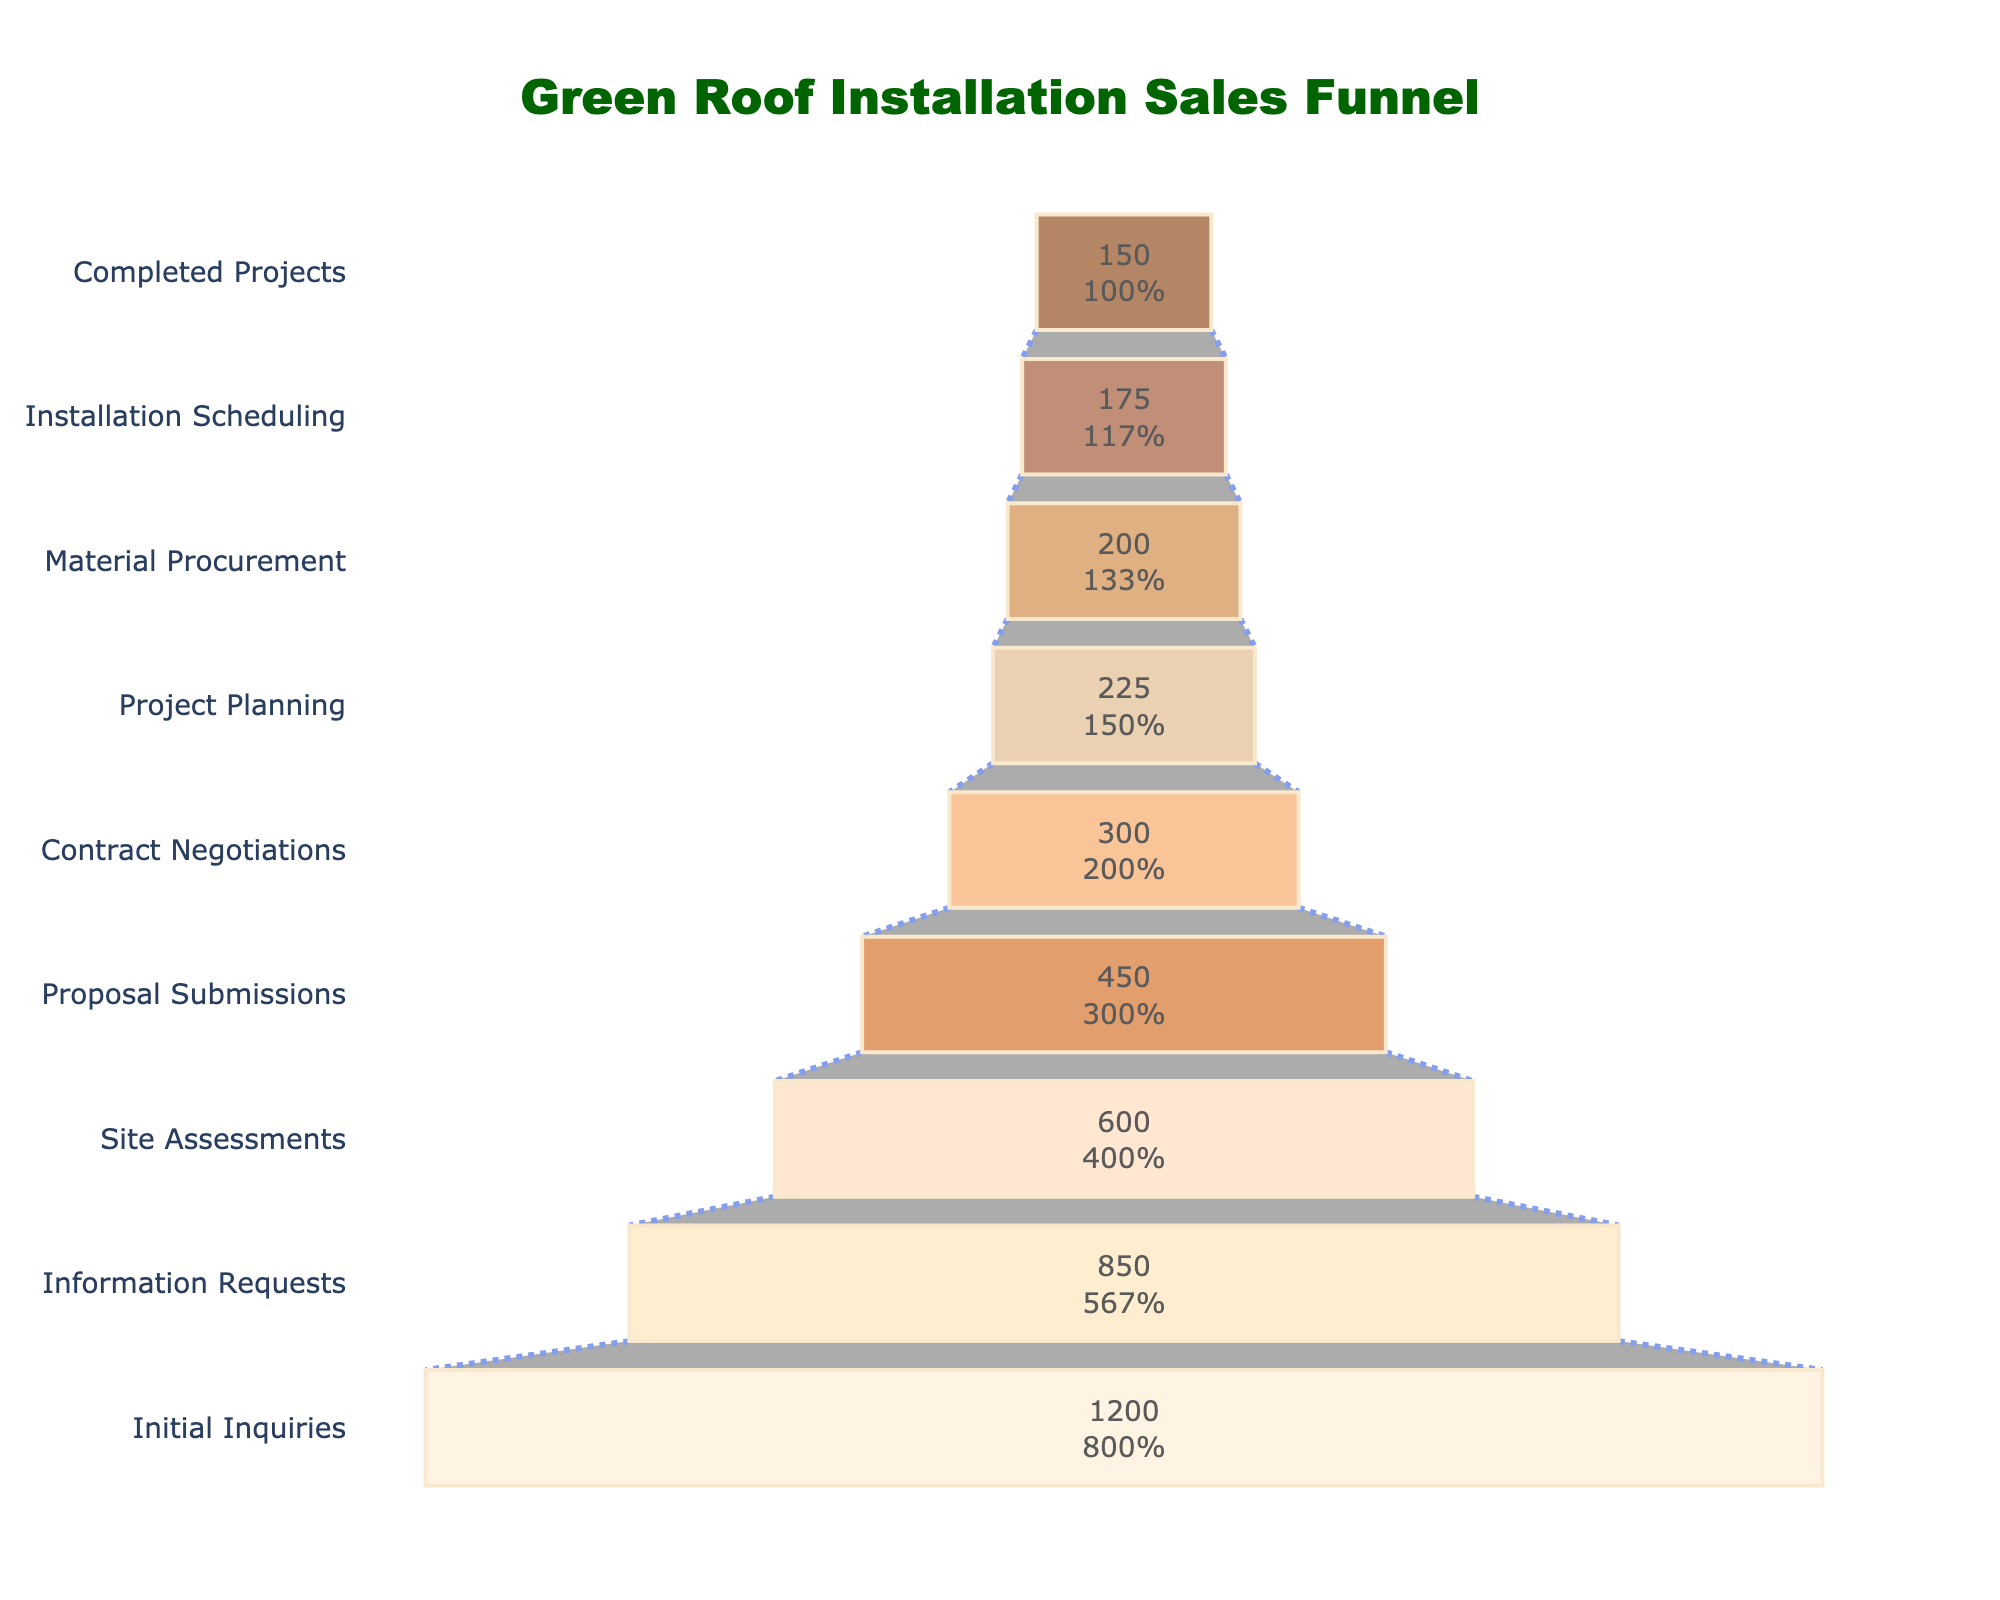what is the title of the figure? The title of the figure is shown at the top of the chart. It reads "Green Roof Installation Sales Funnel."
Answer: Green Roof Installation Sales Funnel how many stages are represented in the sales funnel? By counting the number of segments in the funnel chart, we see there are nine stages.
Answer: Nine what is the count for the 'site assessments' stage? The count for the 'Site Assessments' stage can be read directly from the funnel, which is marked as 600.
Answer: 600 which stage has the lowest count? The stage with the lowest count is at the bottom of the funnel, shown as 'Completed Projects' with a count of 150.
Answer: Completed Projects how does the count for 'proposal submissions' compare to 'contract negotiations'? The count for 'Proposal Submissions' is 450 while 'Contract Negotiations' is 300. Comparing the two, 'Proposal Submissions' has a higher count.
Answer: Proposal Submissions has a higher count what is the percentage of initial inquiries that lead to completed projects? To find the percentage, divide the 'Completed Projects' count by the 'Initial Inquiries' count and multiply by 100. That is (150 / 1200) * 100 = 12.5%.
Answer: 12.5% what is the sum of counts for 'material procurement' and 'installation scheduling'? The counts for 'Material Procurement' and 'Installation Scheduling' are 200 and 175, respectively. Summing them up: 200 + 175 = 375.
Answer: 375 which stage has a count closest to the median stage count? The median can be found by organizing the counts in ascending or descending order and picking the middle value: 150, 175, 200, 225, 300, 450, 600, 850, 1200. The median count is 300, corresponding to 'Contract Negotiations'.
Answer: Contract Negotiations how many fewer counts does 'information requests' have compared to 'initial inquiries'? Subtract the count for 'Information Requests' from 'Initial Inquiries': 1200 - 850 = 350.
Answer: 350 fewer what percentage of the 'proposal submissions' stage moves to 'contract negotiations'? To find the percentage, divide the 'Contract Negotiations' count by the 'Proposal Submissions' count and multiply by 100. That is (300 / 450) * 100 = 66.67%.
Answer: 66.67% 